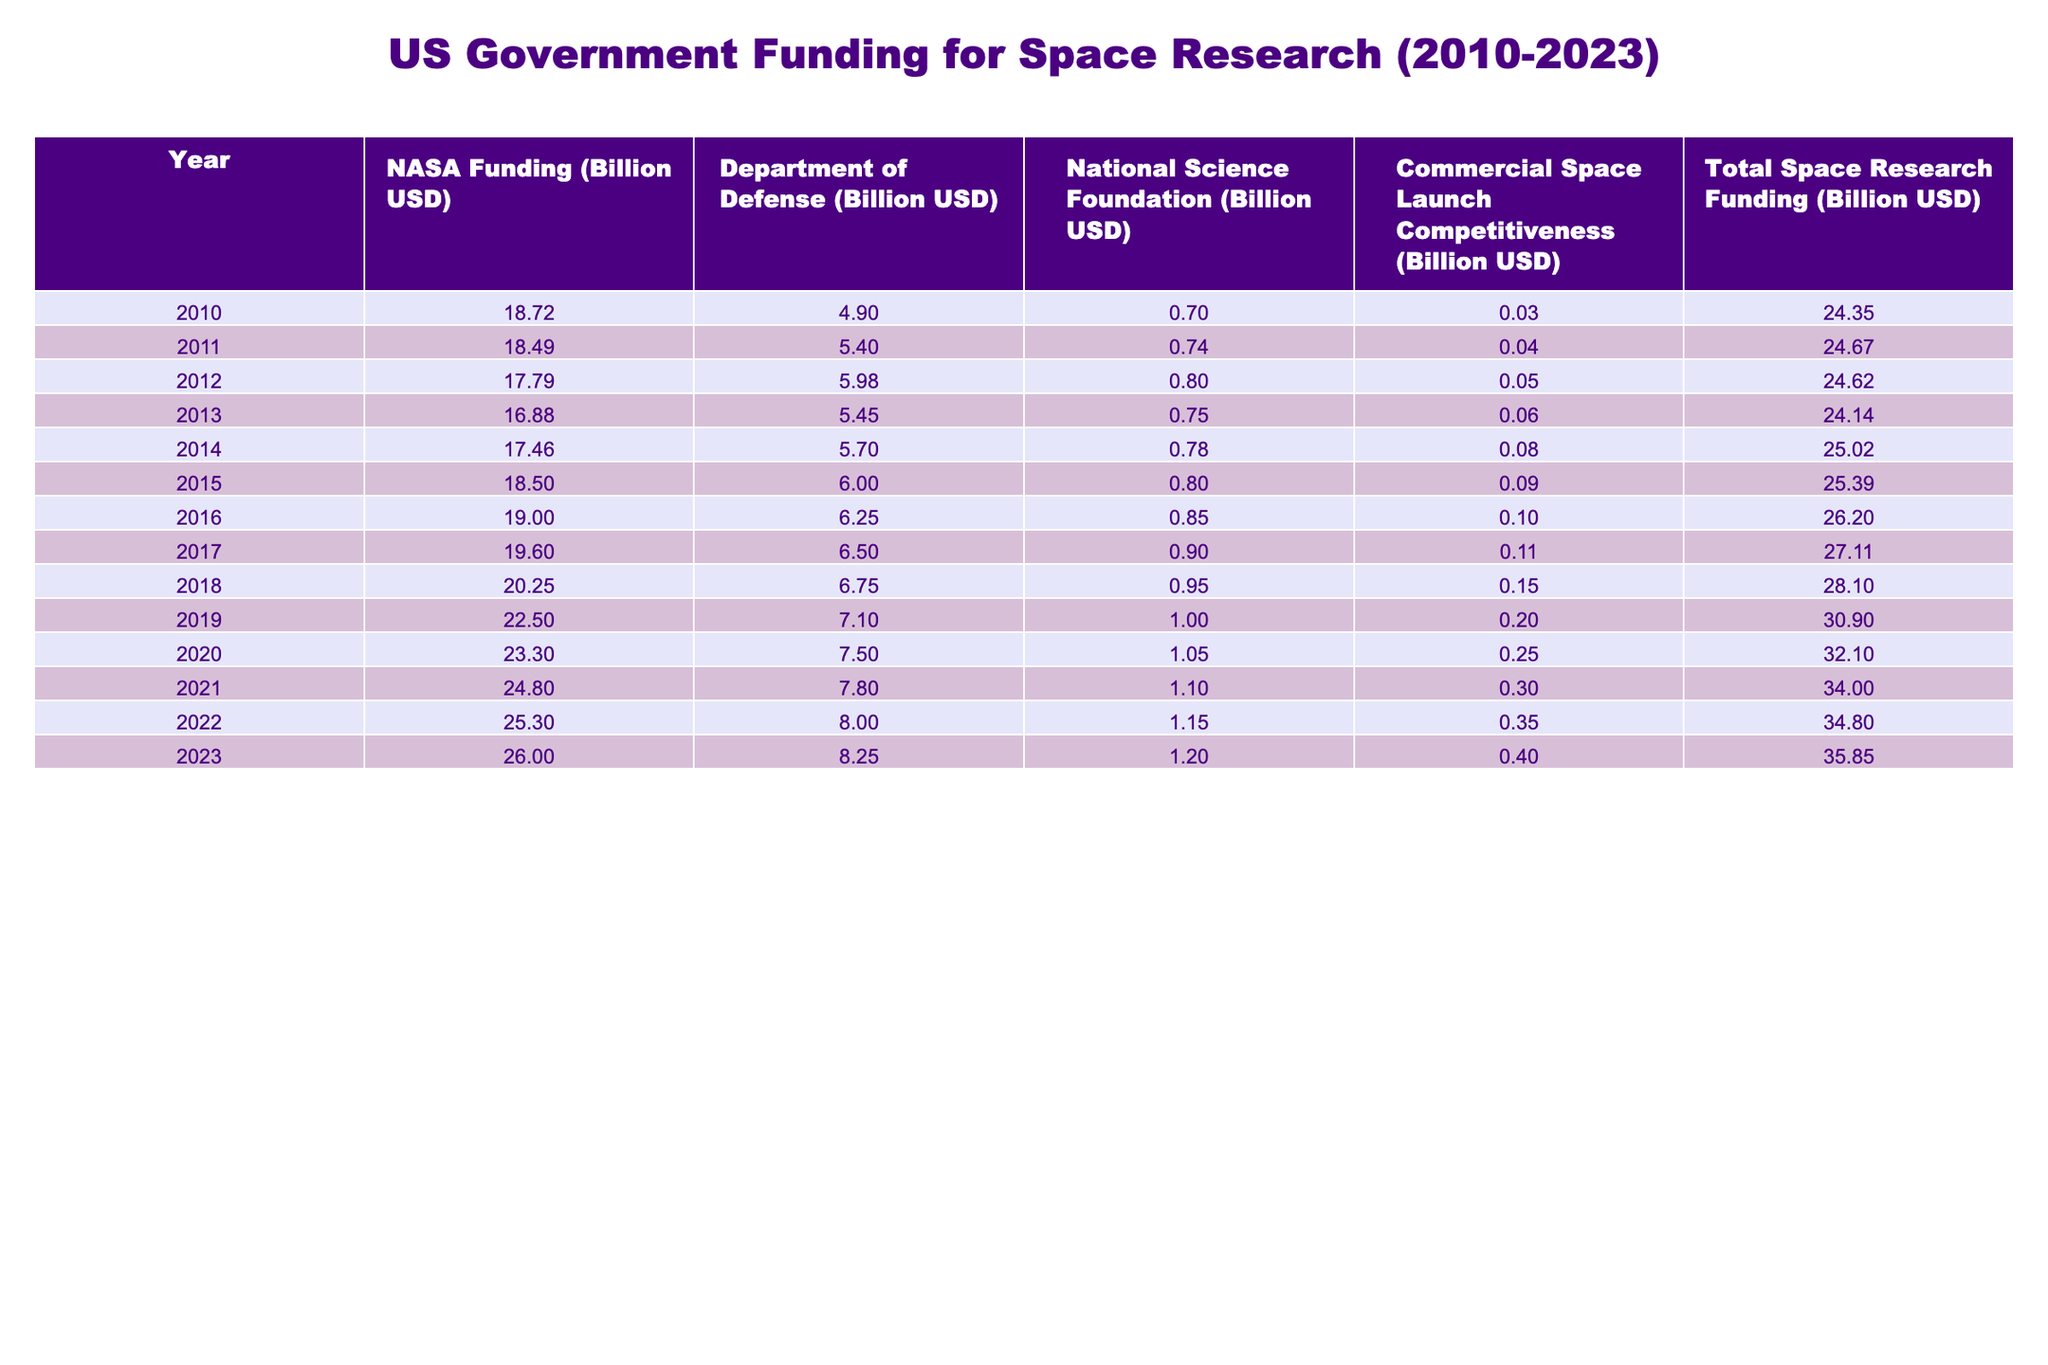What was the total space research funding in 2019? In the table, the total space research funding for 2019 is clearly listed as 30.90 billion USD.
Answer: 30.90 billion USD Which year had the highest NASA funding? Scanning through the NASA funding column, the highest value is 26.00 billion USD, which occurred in 2023.
Answer: 2023 What is the difference between NASA funding in 2010 and 2023? NASA funding in 2010 was 18.72 billion USD and in 2023 it is 26.00 billion USD. The difference is 26.00 - 18.72 = 7.28 billion USD.
Answer: 7.28 billion USD Did National Science Foundation funding increase every year from 2010 to 2023? By looking through the National Science Foundation funding column, the values show a gradual increase each year, confirming that funding did increase every year during this period.
Answer: Yes What was the average Department of Defense funding from 2010 to 2023? To find the average, we first add all the Department of Defense funding values: 4.90 + 5.40 + 5.98 + 5.45 + 5.70 + 6.00 + 6.25 + 6.50 + 7.10 + 7.50 + 7.80 + 8.00 + 8.25 = 77.20 billion USD. Then we divide by the number of years (13): 77.20 / 13 ≈ 5.94 billion USD.
Answer: 5.94 billion USD In which year did the funding from Commercial Space Launch Competitiveness first exceed 0.10 billion USD? Looking at the Commercial Space Launch Competitiveness column, the funding exceeded 0.10 billion USD for the first time in 2016, when it was 0.10 billion USD.
Answer: 2016 What was the total space research funding in 2020 and how does it compare to that in 2010? The total space research funding in 2020 was 32.10 billion USD. The funding in 2010 was 24.35 billion USD. The increase is 32.10 - 24.35 = 7.75 billion USD.
Answer: 7.75 billion USD increase Is the total space research funding in 2022 greater than that in 2021? Comparing the total space research funding, 2022 had 34.80 billion USD and 2021 had 34.00 billion USD. Since 34.80 > 34.00, the statement is true.
Answer: Yes What is the trend for NASA funding from 2010 to 2023? Observing the NASA funding column, the amounts are generally increasing each year from 2010 (18.72) to 2023 (26.00), indicating a positive trend.
Answer: Increasing trend In which years was the total space research funding above 30 billion USD? Checking the total space research funding values, they were above 30 billion USD in 2019 (30.90), 2020 (32.10), 2021 (34.00), 2022 (34.80), and 2023 (35.85).
Answer: 2019, 2020, 2021, 2022, 2023 If the funding from the National Science Foundation is combined with NASA funding for the year 2021, what is the total? For 2021, NASA funding is 24.80 billion USD and National Science Foundation funding is 1.10 billion USD. Adding these gives 24.80 + 1.10 = 25.90 billion USD.
Answer: 25.90 billion USD 